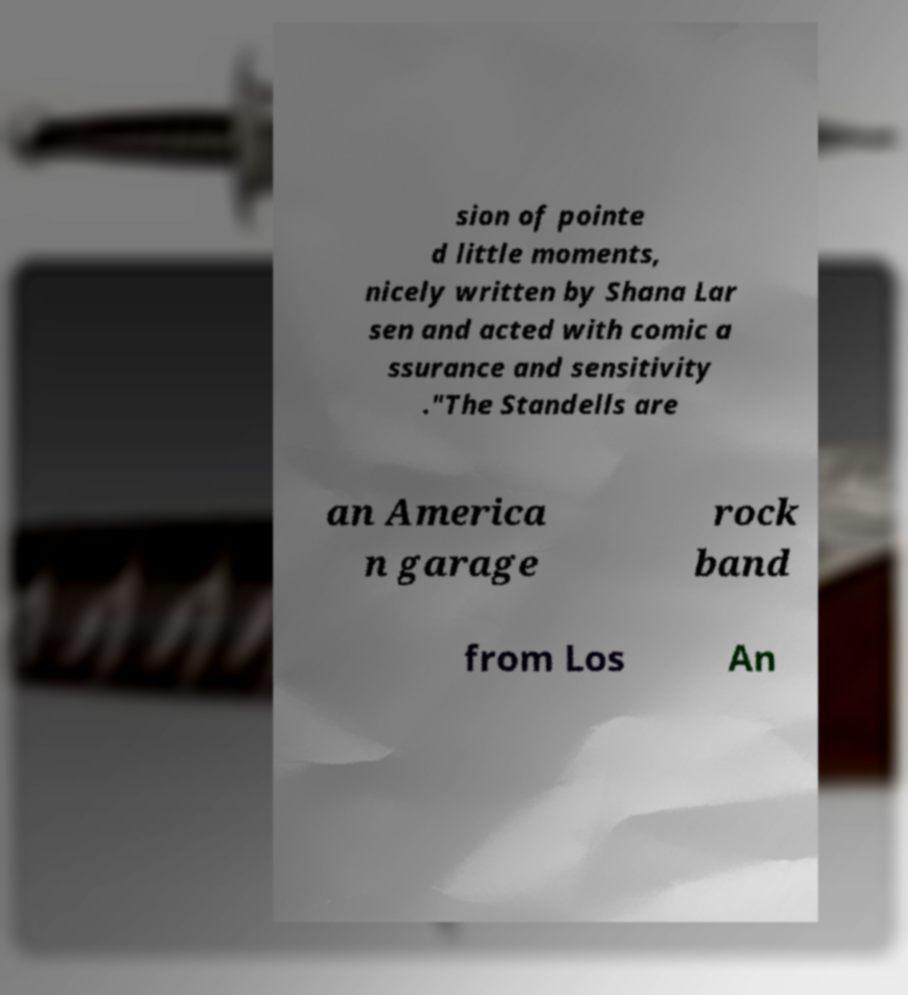Please read and relay the text visible in this image. What does it say? sion of pointe d little moments, nicely written by Shana Lar sen and acted with comic a ssurance and sensitivity ."The Standells are an America n garage rock band from Los An 